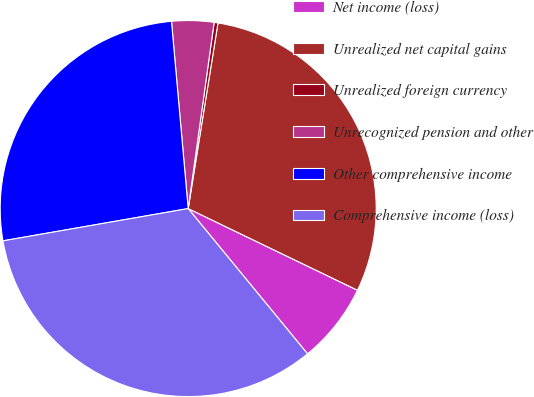Convert chart. <chart><loc_0><loc_0><loc_500><loc_500><pie_chart><fcel>Net income (loss)<fcel>Unrealized net capital gains<fcel>Unrealized foreign currency<fcel>Unrecognized pension and other<fcel>Other comprehensive income<fcel>Comprehensive income (loss)<nl><fcel>6.9%<fcel>29.62%<fcel>0.33%<fcel>3.62%<fcel>26.33%<fcel>33.2%<nl></chart> 